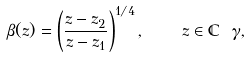<formula> <loc_0><loc_0><loc_500><loc_500>\beta ( z ) = \left ( \frac { z - z _ { 2 } } { z - z _ { 1 } } \right ) ^ { 1 / 4 } , \quad z \in \mathbb { C } \ \gamma ,</formula> 